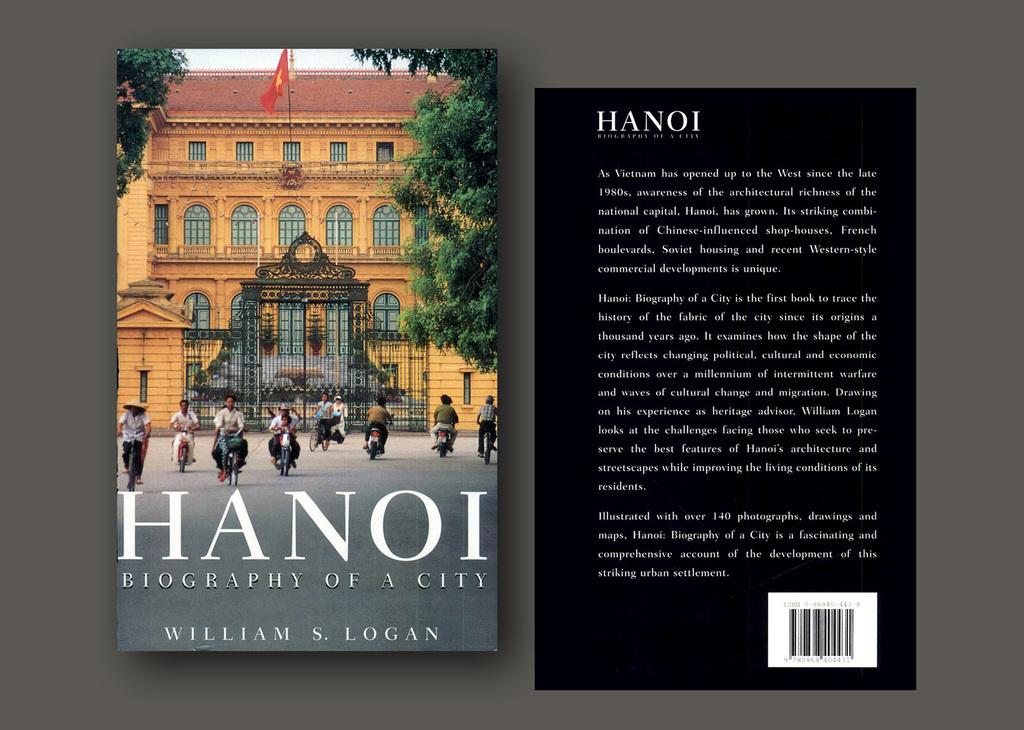<image>
Provide a brief description of the given image. The book Hanoi, Biography of a City written by William S. Logan. 